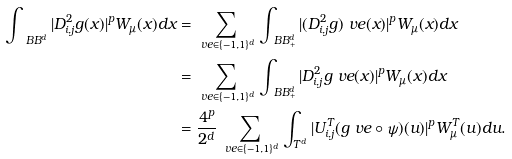<formula> <loc_0><loc_0><loc_500><loc_500>\int _ { \ B B ^ { d } } | D ^ { 2 } _ { i , j } g ( x ) | ^ { p } W _ { \mu } ( x ) d x & = \sum _ { \ v e \in \{ - 1 , 1 \} ^ { d } } \int _ { \ B B ^ { d } _ { + } } | ( D _ { i , j } ^ { 2 } g ) _ { \ } v e ( x ) | ^ { p } W _ { \mu } ( x ) d x \\ & = \sum _ { \ v e \in \{ - 1 , 1 \} ^ { d } } \int _ { \ B B ^ { d } _ { + } } | D _ { i , j } ^ { 2 } g _ { \ } v e ( x ) | ^ { p } W _ { \mu } ( x ) d x \\ & = \frac { 4 ^ { p } } { 2 ^ { d } } \sum _ { \ v e \in \{ - 1 , 1 \} ^ { d } } \int _ { T ^ { d } } | U _ { i , j } ^ { T } ( g _ { \ } v e \circ \psi ) ( u ) | ^ { p } W _ { \mu } ^ { T } ( u ) d u .</formula> 